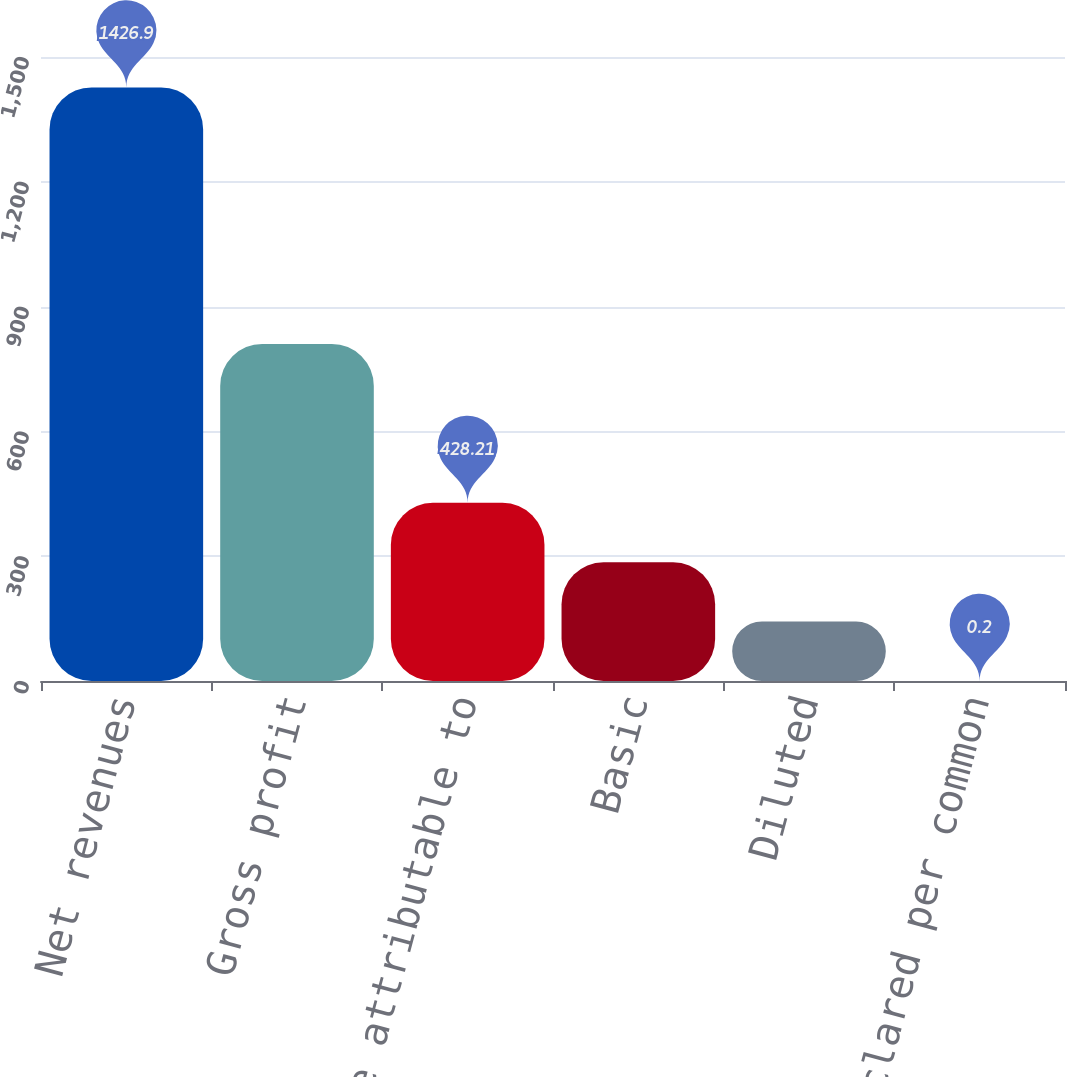<chart> <loc_0><loc_0><loc_500><loc_500><bar_chart><fcel>Net revenues<fcel>Gross profit<fcel>Net income attributable to<fcel>Basic<fcel>Diluted<fcel>Dividends declared per common<nl><fcel>1426.9<fcel>810.3<fcel>428.21<fcel>285.54<fcel>142.87<fcel>0.2<nl></chart> 